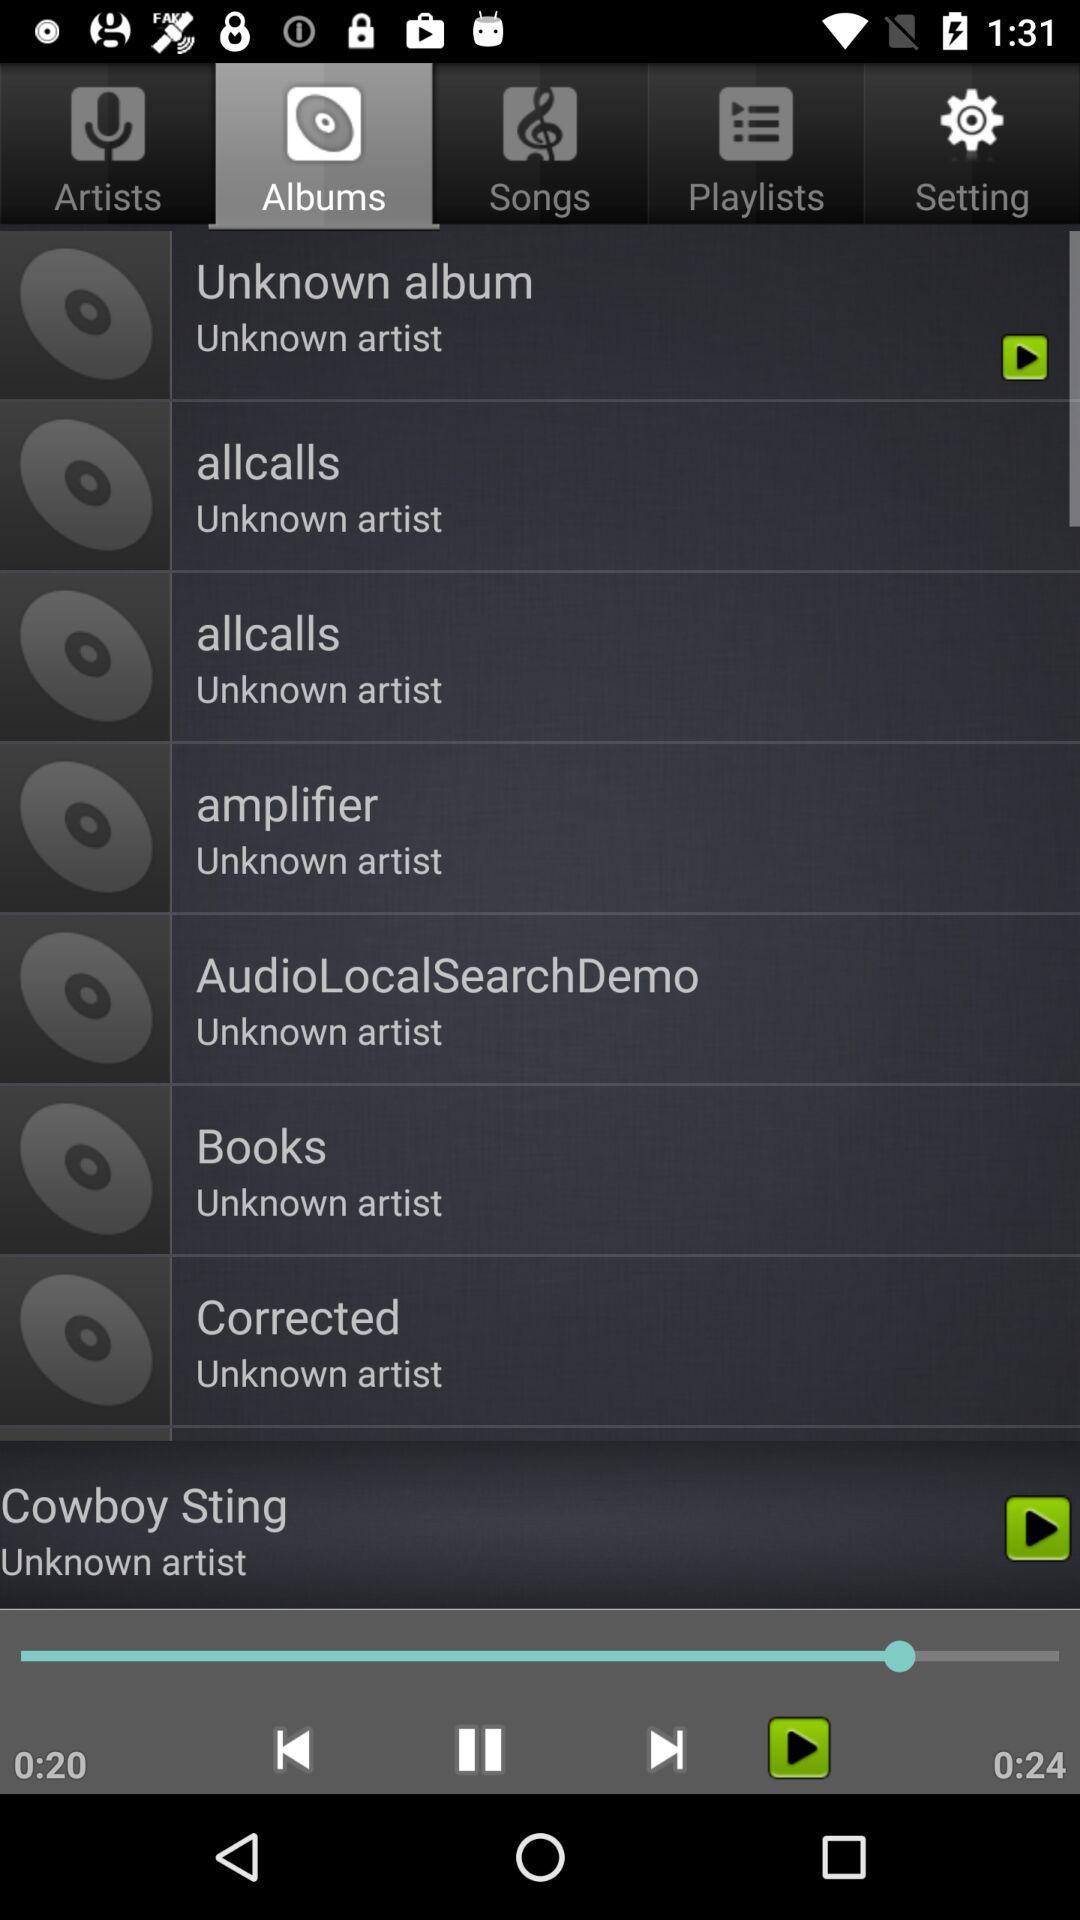Which song is playing? The song that is playing is "Cowboy Sting". 